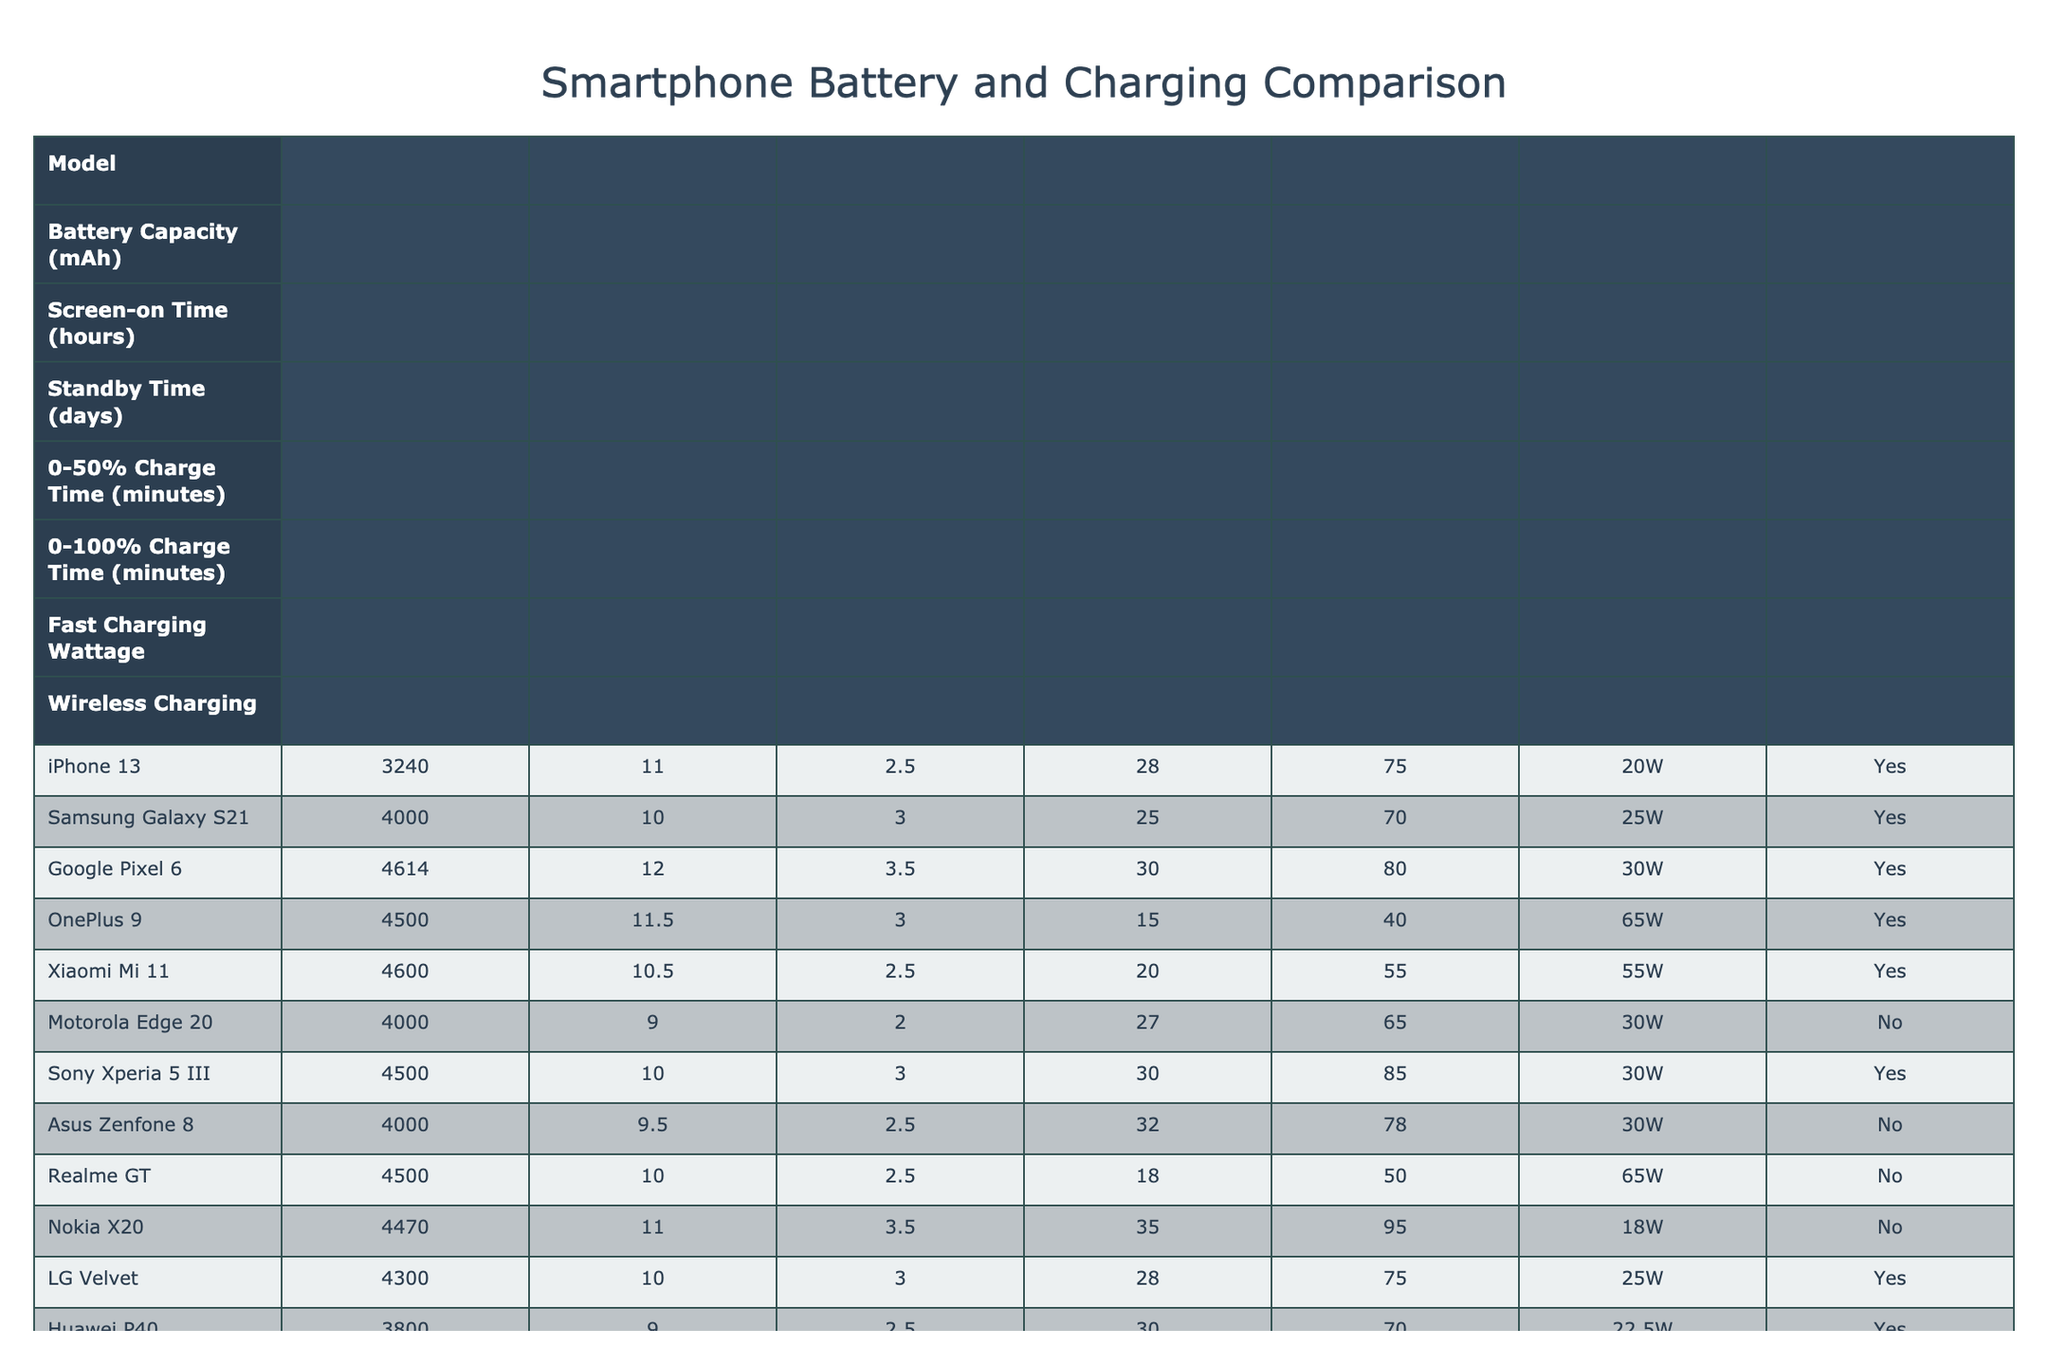What is the battery capacity of the Google Pixel 6? The table lists the Google Pixel 6 under the "Model" column, and its corresponding "Battery Capacity" is shown as 4614 mAh.
Answer: 4614 mAh Which smartphone has the longest screen-on time? By looking at the "Screen-on Time" column, the maximum value is 12 hours for the Google Pixel 6.
Answer: Google Pixel 6 Does the Samsung Galaxy S21 support wireless charging? In the "Wireless Charging" column for the Samsung Galaxy S21, it indicates "Yes," confirming it supports this feature.
Answer: Yes What is the 0-100% charge time for the OnePlus 9? The table shows the "0-100% Charge Time" for the OnePlus 9 as 40 minutes.
Answer: 40 minutes Which phone has the highest fast charging wattage? The table reveals that the OnePlus 9 has the highest fast charging wattage of 65W.
Answer: OnePlus 9 What is the average battery capacity of all listed smartphones? The battery capacities are 3240, 4000, 4614, 4500, 4600, 4000, 4500, 4000, 4470, 4300, 3800, 4500, 4300. Summing these gives 55,104 mAh, and there are 13 models, so the average is 55,104 / 13 ≈ 4,248 mAh.
Answer: 4248 mAh How many smartphones have a standby time greater than 3 days? Scanning through the "Standby Time" column, only the Google Pixel 6 and Nokia X20 list standby times greater than 3 days (specifically 3.5 days each). Thus, the count is 2 phones.
Answer: 2 smartphones What is the difference in fast charging wattage between the OnePlus 9 and Xiaomi Mi 11? The fast charging wattage for the OnePlus 9 is 65W and for the Xiaomi Mi 11, it is 55W. The difference is 65 - 55 = 10W.
Answer: 10W Which smartphone has the shortest time to charge from 0-50%? By checking the "0-50% Charge Time" column, the OnePlus 9 has the shortest charging time listed as 15 minutes.
Answer: OnePlus 9 If you want the device with the best combination of battery capacity and screen-on time, which one would it be? To find this, we can look for the highest values in both the "Battery Capacity" and "Screen-on Time" columns. The Google Pixel 6 has a high battery capacity of 4614 mAh and screen-on time of 12 hours, making it the best combination.
Answer: Google Pixel 6 